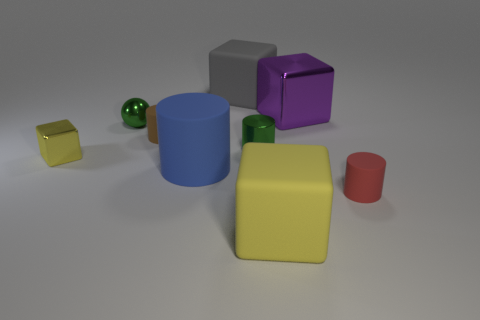What number of big blocks have the same color as the tiny metallic cube?
Provide a short and direct response. 1. Are there fewer shiny balls on the right side of the large gray cube than tiny shiny objects that are left of the brown matte object?
Your answer should be compact. Yes. There is a green shiny thing right of the blue cylinder; what is its size?
Offer a terse response. Small. There is another block that is the same color as the small cube; what size is it?
Keep it short and to the point. Large. Is there a small red cylinder made of the same material as the brown object?
Your response must be concise. Yes. Do the big blue cylinder and the large gray block have the same material?
Your answer should be very brief. Yes. The shiny cube that is the same size as the blue thing is what color?
Your answer should be very brief. Purple. What number of other objects are the same shape as the red object?
Provide a short and direct response. 3. There is a purple cube; does it have the same size as the yellow cube right of the brown rubber thing?
Offer a very short reply. Yes. What number of things are purple balls or small green things?
Make the answer very short. 2. 